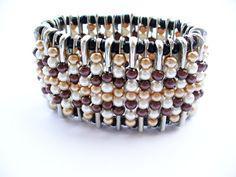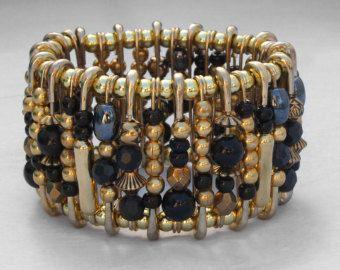The first image is the image on the left, the second image is the image on the right. Analyze the images presented: Is the assertion "All images are bracelets sitting the same position on a plain, solid colored surface." valid? Answer yes or no. Yes. The first image is the image on the left, the second image is the image on the right. Considering the images on both sides, is "The bracelet in the image on the right uses a clasp to close." valid? Answer yes or no. No. 